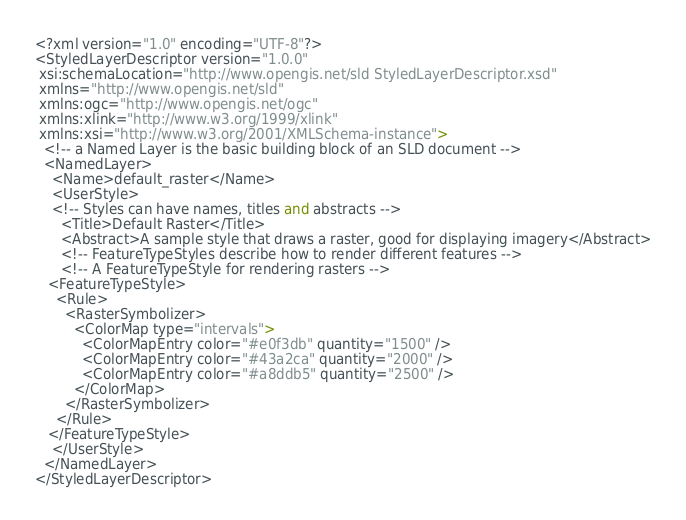Convert code to text. <code><loc_0><loc_0><loc_500><loc_500><_Scheme_><?xml version="1.0" encoding="UTF-8"?>
<StyledLayerDescriptor version="1.0.0" 
 xsi:schemaLocation="http://www.opengis.net/sld StyledLayerDescriptor.xsd" 
 xmlns="http://www.opengis.net/sld" 
 xmlns:ogc="http://www.opengis.net/ogc" 
 xmlns:xlink="http://www.w3.org/1999/xlink" 
 xmlns:xsi="http://www.w3.org/2001/XMLSchema-instance">
  <!-- a Named Layer is the basic building block of an SLD document -->
  <NamedLayer>
    <Name>default_raster</Name>
    <UserStyle>
    <!-- Styles can have names, titles and abstracts -->
      <Title>Default Raster</Title>
      <Abstract>A sample style that draws a raster, good for displaying imagery</Abstract>
      <!-- FeatureTypeStyles describe how to render different features -->
      <!-- A FeatureTypeStyle for rendering rasters -->
   <FeatureTypeStyle>
     <Rule>
       <RasterSymbolizer>
         <ColorMap type="intervals">
           <ColorMapEntry color="#e0f3db" quantity="1500" />
           <ColorMapEntry color="#43a2ca" quantity="2000" />
           <ColorMapEntry color="#a8ddb5" quantity="2500" />
         </ColorMap>
       </RasterSymbolizer>
     </Rule>
   </FeatureTypeStyle>
    </UserStyle>
  </NamedLayer>
</StyledLayerDescriptor>
</code> 